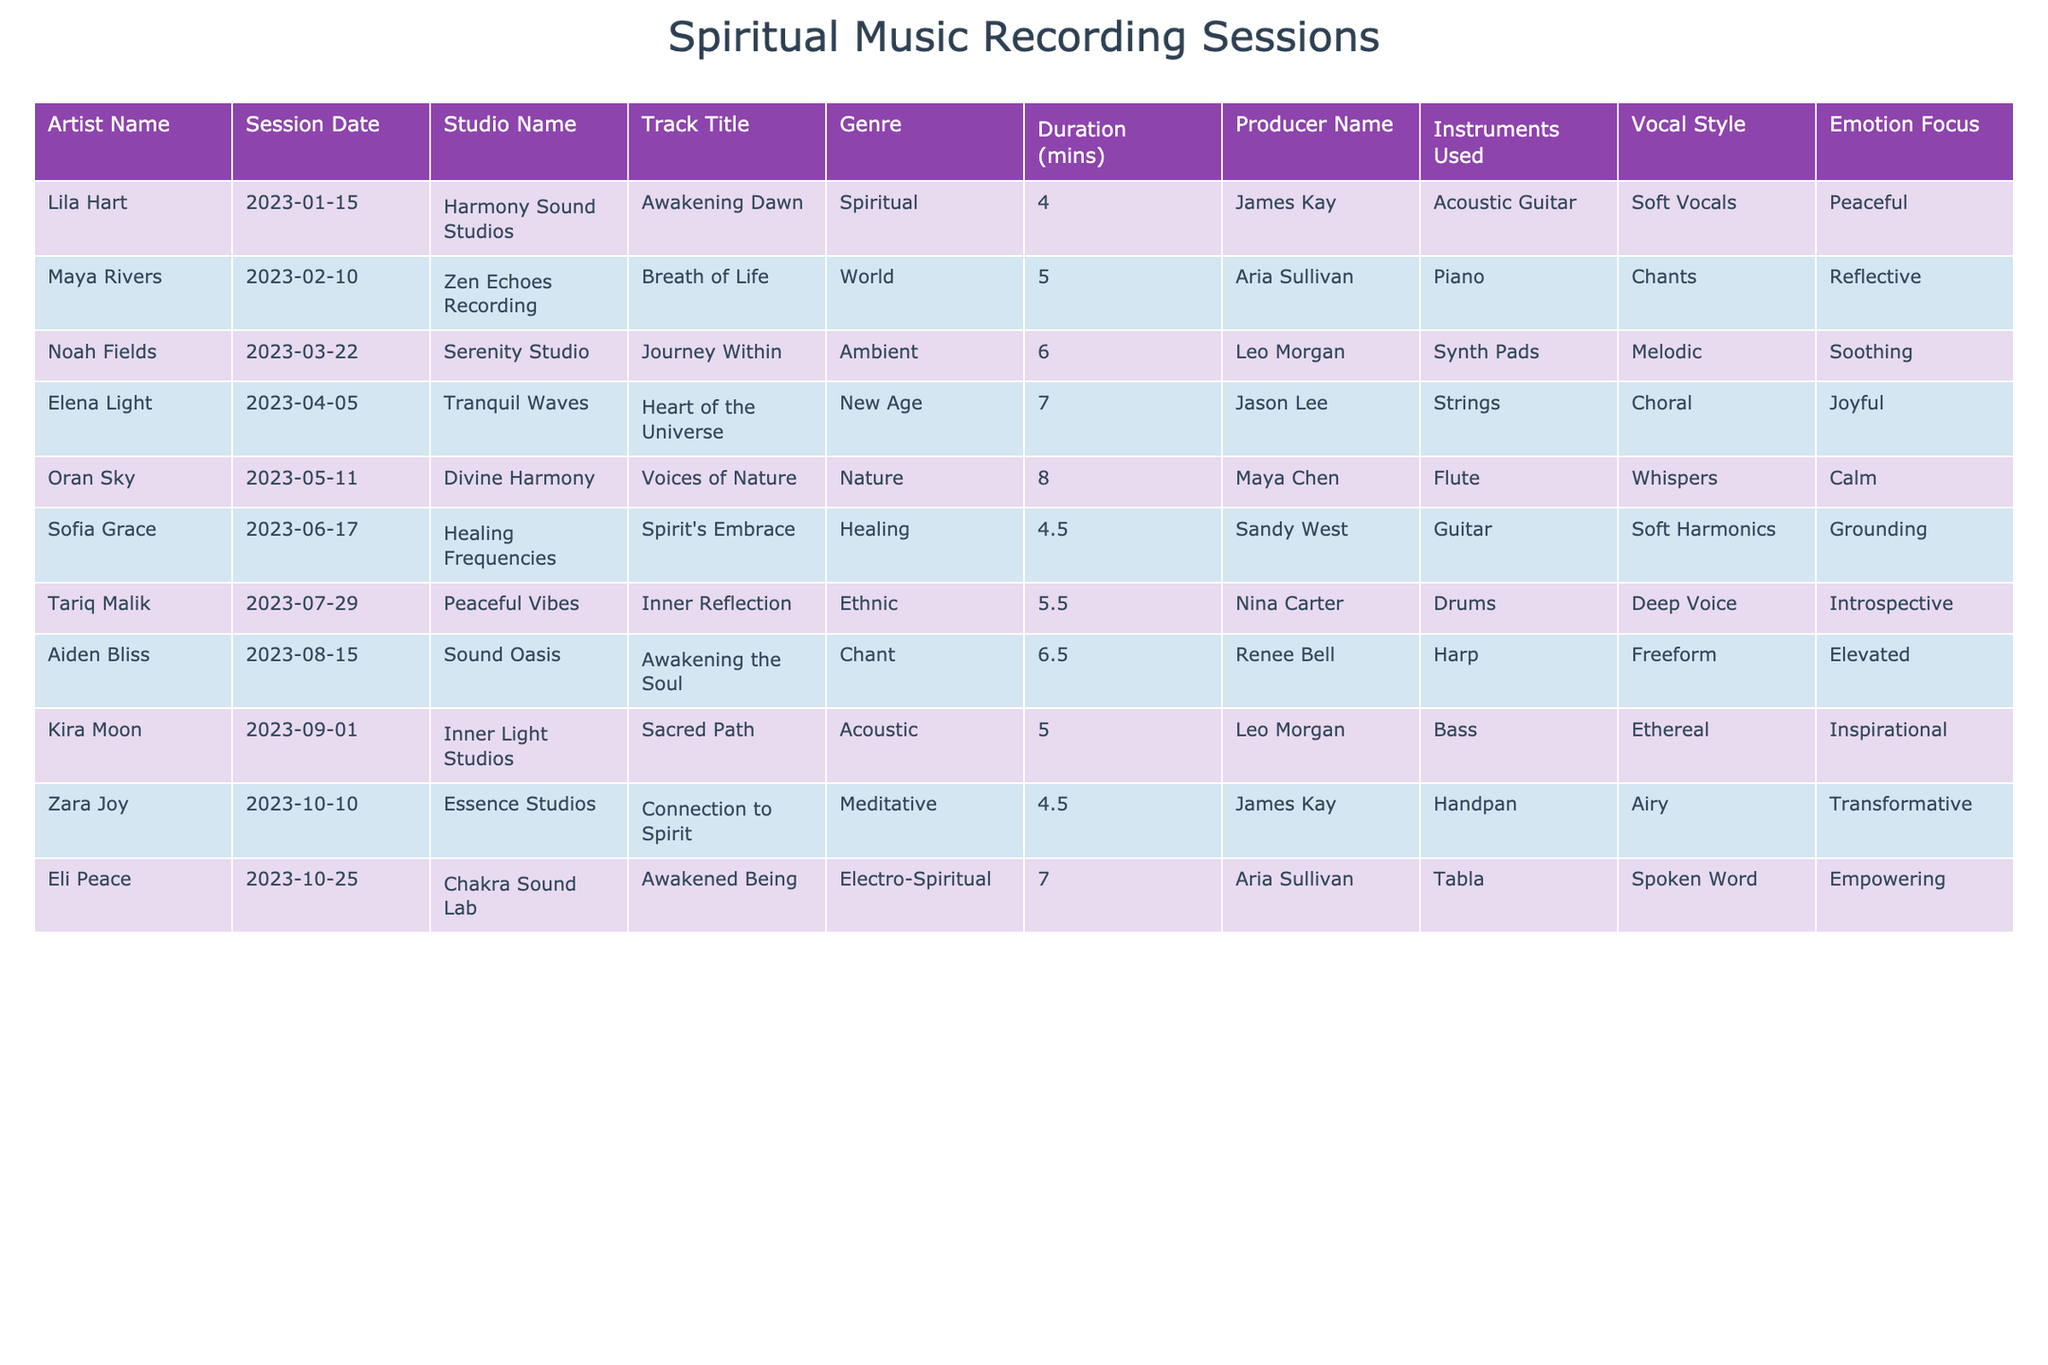What is the total duration of all the recording sessions? Summing the durations: 4 + 5 + 6 + 7 + 8 + 4.5 + 5.5 + 6.5 + 5 + 4.5 + 7 = 57.5 minutes
Answer: 57.5 minutes Which artist recorded the longest track and what is its duration? The track titled "Voices of Nature" by Oran Sky has the longest duration of 8 minutes
Answer: Oran Sky, 8 minutes How many sessions are classified under the genre 'Spiritual'? There is 1 session titled "Awakening Dawn" by Lila Hart that is classified as a Spiritual genre
Answer: 1 session Which producer worked with the most artists and how many artists did they work with? James Kay produced sessions for 2 artists, Lila Hart and Zara Joy
Answer: James Kay, 2 artists Is there any session that focuses on the emotion 'Joyful'? Yes, "Heart of the Universe" by Elena Light focuses on the emotion 'Joyful'
Answer: Yes What is the average duration of the sessions recorded in 'Acoustic' genre? The sessions in Acoustic genre are "Awakening Dawn" (4 mins), "Sacred Path" (5 mins), average = (4 + 5) / 2 = 4.5 minutes
Answer: 4.5 minutes Who produced 'Inner Reflection' and what is the vocal style used? "Inner Reflection" was produced by Nina Carter and features a Deep Voice vocal style
Answer: Nina Carter, Deep Voice What emotion is focused on the track 'Connection to Spirit'? The emotion focus of "Connection to Spirit" is Transformative
Answer: Transformative Count the number of sessions that use instruments with a 'Choral' vocal style. There is 1 session titled "Heart of the Universe" by Elena Light that uses a Choral style
Answer: 1 session Are there any tracks that feature the use of drums? Yes, "Inner Reflection" by Tariq Malik features the use of drums
Answer: Yes What is the total number of different studio names used across all the sessions? The unique studio names are Harmony Sound Studios, Zen Echoes Recording, Serenity Studio, Tranquil Waves, Divine Harmony, Healing Frequencies, Peaceful Vibes, Sound Oasis, Inner Light Studios, Essence Studios, and Chakra Sound Lab. That's 11 unique studios
Answer: 11 studios 